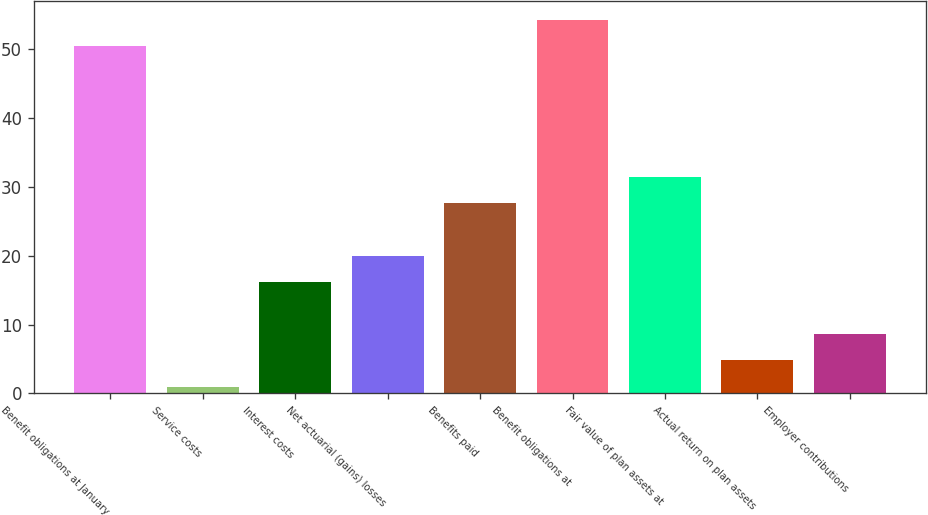Convert chart. <chart><loc_0><loc_0><loc_500><loc_500><bar_chart><fcel>Benefit obligations at January<fcel>Service costs<fcel>Interest costs<fcel>Net actuarial (gains) losses<fcel>Benefits paid<fcel>Benefit obligations at<fcel>Fair value of plan assets at<fcel>Actual return on plan assets<fcel>Employer contributions<nl><fcel>50.4<fcel>1<fcel>16.2<fcel>20<fcel>27.6<fcel>54.2<fcel>31.4<fcel>4.8<fcel>8.6<nl></chart> 